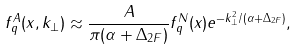<formula> <loc_0><loc_0><loc_500><loc_500>f _ { q } ^ { A } ( x , k _ { \perp } ) \approx \frac { A } { \pi ( \alpha + \Delta _ { 2 F } ) } f _ { q } ^ { N } ( x ) e ^ { - k _ { \perp } ^ { 2 } / ( \alpha + \Delta _ { 2 F } ) } ,</formula> 